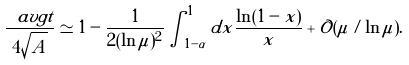Convert formula to latex. <formula><loc_0><loc_0><loc_500><loc_500>\frac { \ a v g { t } } { 4 \sqrt { A } } \simeq 1 - \frac { 1 } { 2 ( \ln \mu ) ^ { 2 } } \int _ { 1 - \alpha } ^ { 1 } d x \frac { \ln ( 1 - x ) } { x } + \mathcal { O } ( \mu / \ln \mu ) .</formula> 